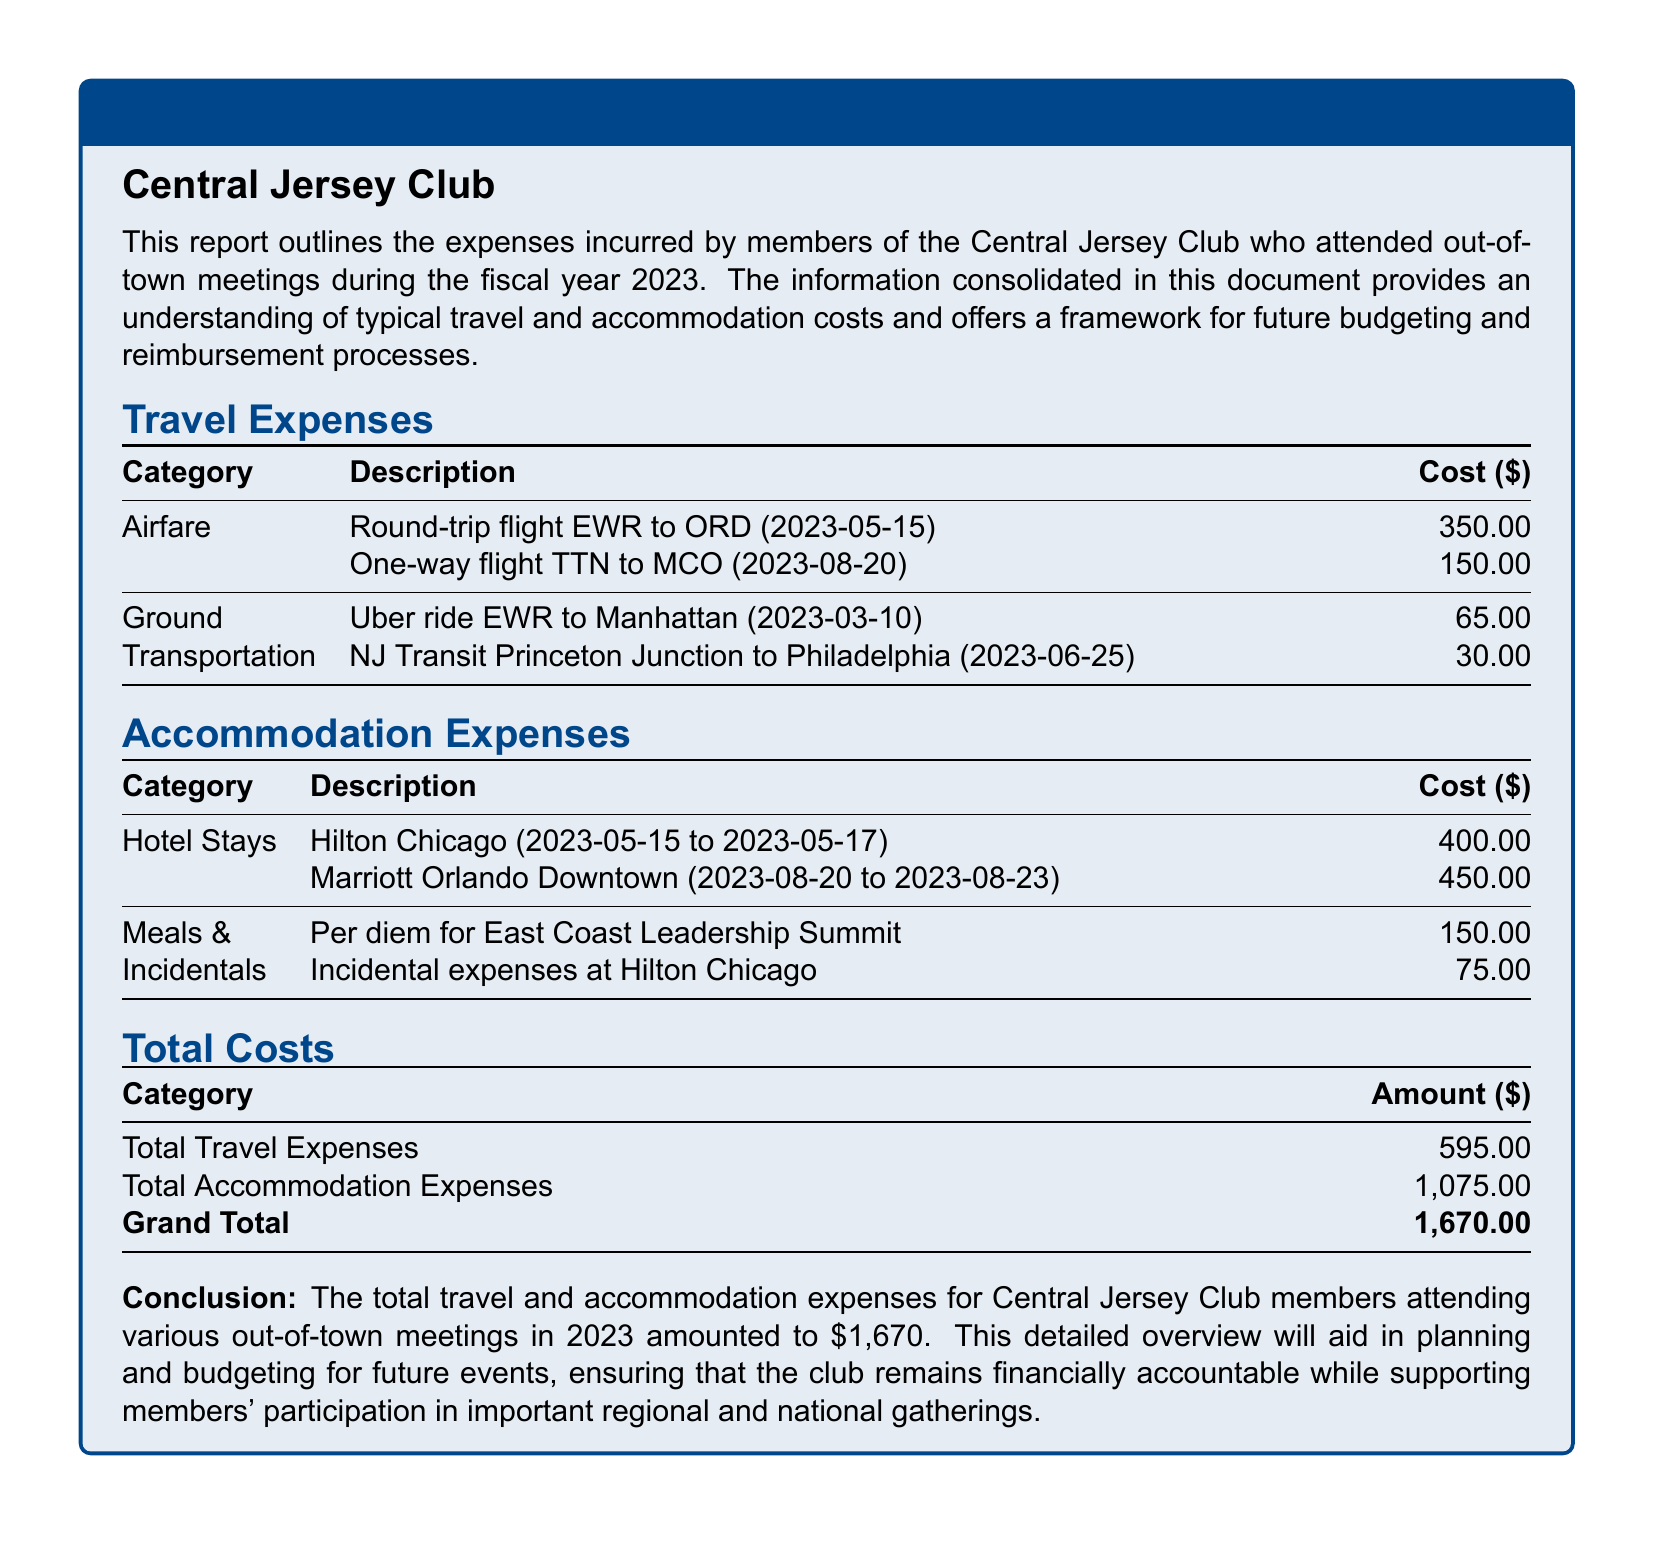what is the total travel expenses? The total travel expenses are outlined in the document, which are calculated as $350 plus $150 plus $65 plus $30.
Answer: $595.00 what is the total accommodation expenses? The total accommodation expenses are calculated by adding all accommodation-related costs, which include $400, $450, $150, and $75.
Answer: $1,075.00 how much was spent on the hotel stay at Hilton Chicago? The hotel stay cost for Hilton Chicago is listed in the accommodation section of the document.
Answer: $400.00 how many different types of transportation are noted? The document specifies the types of transportation used for travel, which are airfare and ground transportation, providing two distinct categories.
Answer: 2 what is the grand total of expenses? The grand total is a summary figure that combines total travel expenses and total accommodation expenses presented in the document.
Answer: $1,670.00 when was the round-trip flight from EWR to ORD taken? The round-trip flight details include the date of travel, which is provided in the travel expenses section.
Answer: 2023-05-15 what is the per diem amount for the East Coast Leadership Summit? The document specifies the per diem amount listed under meals and incidentals, which is a component of accommodation expenses.
Answer: $150.00 which hotel was used in Orlando? The accommodation details clarify the name of the hotel where the members stayed in Orlando during their travels.
Answer: Marriott Orlando Downtown how much was reimbursed for incidental expenses at Hilton Chicago? The incidentals listed under accommodation expenses provide a specific amount reimbursed for those expenses.
Answer: $75.00 